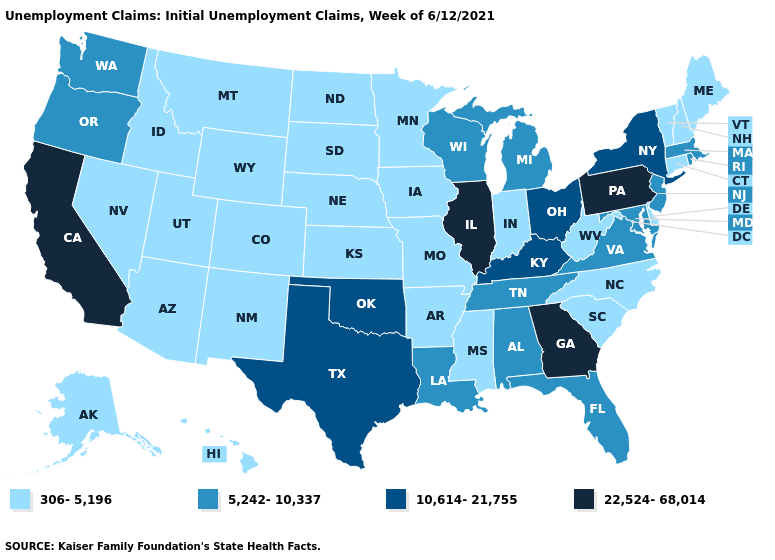What is the value of New York?
Quick response, please. 10,614-21,755. What is the highest value in states that border California?
Answer briefly. 5,242-10,337. Name the states that have a value in the range 10,614-21,755?
Keep it brief. Kentucky, New York, Ohio, Oklahoma, Texas. What is the value of Massachusetts?
Short answer required. 5,242-10,337. Among the states that border California , which have the highest value?
Answer briefly. Oregon. Name the states that have a value in the range 306-5,196?
Write a very short answer. Alaska, Arizona, Arkansas, Colorado, Connecticut, Delaware, Hawaii, Idaho, Indiana, Iowa, Kansas, Maine, Minnesota, Mississippi, Missouri, Montana, Nebraska, Nevada, New Hampshire, New Mexico, North Carolina, North Dakota, South Carolina, South Dakota, Utah, Vermont, West Virginia, Wyoming. Name the states that have a value in the range 5,242-10,337?
Quick response, please. Alabama, Florida, Louisiana, Maryland, Massachusetts, Michigan, New Jersey, Oregon, Rhode Island, Tennessee, Virginia, Washington, Wisconsin. Name the states that have a value in the range 5,242-10,337?
Give a very brief answer. Alabama, Florida, Louisiana, Maryland, Massachusetts, Michigan, New Jersey, Oregon, Rhode Island, Tennessee, Virginia, Washington, Wisconsin. Does Georgia have the highest value in the USA?
Answer briefly. Yes. Name the states that have a value in the range 22,524-68,014?
Write a very short answer. California, Georgia, Illinois, Pennsylvania. What is the value of Indiana?
Give a very brief answer. 306-5,196. Among the states that border Louisiana , does Arkansas have the highest value?
Write a very short answer. No. Among the states that border New Mexico , which have the lowest value?
Answer briefly. Arizona, Colorado, Utah. What is the lowest value in the USA?
Answer briefly. 306-5,196. Name the states that have a value in the range 306-5,196?
Be succinct. Alaska, Arizona, Arkansas, Colorado, Connecticut, Delaware, Hawaii, Idaho, Indiana, Iowa, Kansas, Maine, Minnesota, Mississippi, Missouri, Montana, Nebraska, Nevada, New Hampshire, New Mexico, North Carolina, North Dakota, South Carolina, South Dakota, Utah, Vermont, West Virginia, Wyoming. 